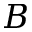<formula> <loc_0><loc_0><loc_500><loc_500>B</formula> 